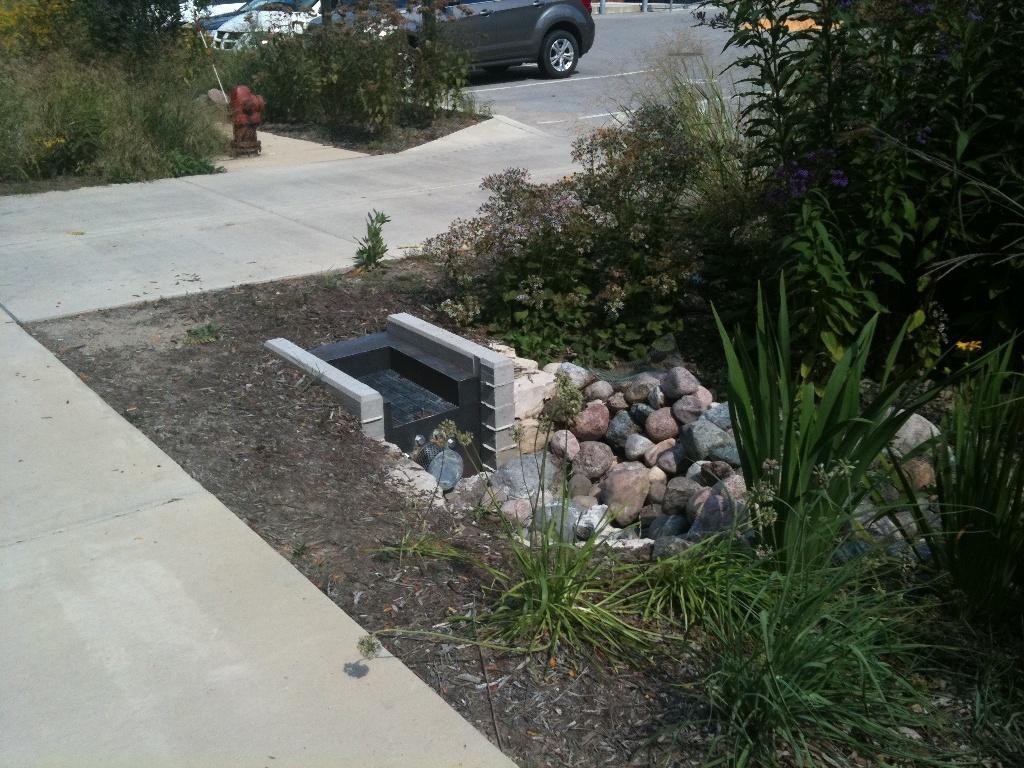In one or two sentences, can you explain what this image depicts? In this picture we a can observe a path. There are some stones on the right side. We can observe some plants. There is a red color fire hydrant. In the background there are some cars on the road. 